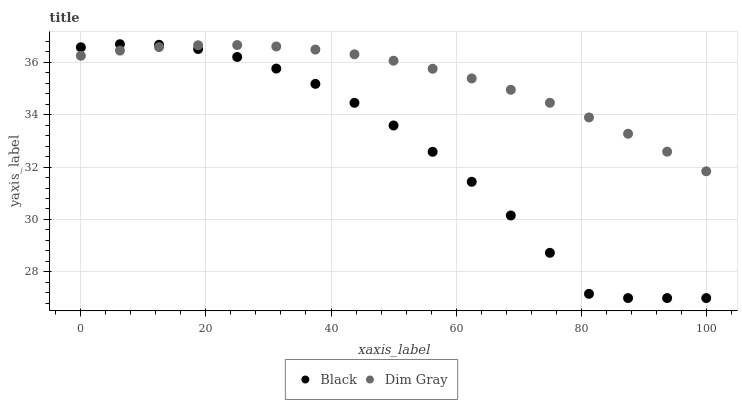Does Black have the minimum area under the curve?
Answer yes or no. Yes. Does Dim Gray have the maximum area under the curve?
Answer yes or no. Yes. Does Black have the maximum area under the curve?
Answer yes or no. No. Is Dim Gray the smoothest?
Answer yes or no. Yes. Is Black the roughest?
Answer yes or no. Yes. Is Black the smoothest?
Answer yes or no. No. Does Black have the lowest value?
Answer yes or no. Yes. Does Black have the highest value?
Answer yes or no. Yes. Does Black intersect Dim Gray?
Answer yes or no. Yes. Is Black less than Dim Gray?
Answer yes or no. No. Is Black greater than Dim Gray?
Answer yes or no. No. 